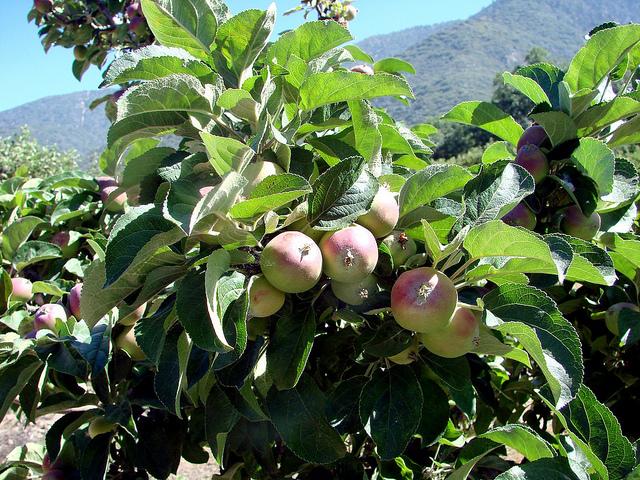How many apple are on the tree?
Write a very short answer. 17. What kind of fruit is hanging from the tree in the forefront?
Keep it brief. Peaches. Is the fruit ripe?
Answer briefly. No. What type of tree is in the photo?
Write a very short answer. Peach. What type of tree is that?
Give a very brief answer. Apple. What is growing on the tree?
Concise answer only. Peaches. What color is the sky?
Concise answer only. Blue. Do these leaves have sun scald?
Quick response, please. No. 